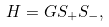<formula> <loc_0><loc_0><loc_500><loc_500>H = G S _ { + } S _ { - } ,</formula> 